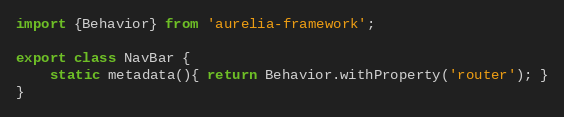<code> <loc_0><loc_0><loc_500><loc_500><_JavaScript_>import {Behavior} from 'aurelia-framework';

export class NavBar {
    static metadata(){ return Behavior.withProperty('router'); }
}
</code> 